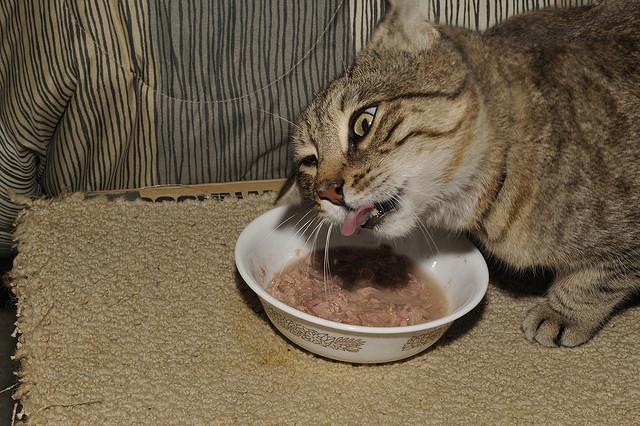What surface is the cat laying on?
Quick response, please. Rug. Do felines sleep?
Write a very short answer. Yes. What are the owners trying to do with the object under the cat?
Be succinct. Feed him. What color is the cat's collar?
Be succinct. Black. What is the bowl used for?
Answer briefly. Cat food. What color is the cup?
Concise answer only. White. Will the cat eat all of the food?
Concise answer only. Yes. How many cats are in the scene?
Write a very short answer. 1. Is the kitten adorable?
Keep it brief. Yes. What color is the bowl on the left?
Quick response, please. White. Is the cat sleeping?
Be succinct. No. Is this bowl too big for the kitten?
Concise answer only. No. Does the cat have on a collar?
Write a very short answer. No. What is the cat eating?
Answer briefly. Tuna. What color is the cat?
Keep it brief. Brown. Does this cat look content?
Concise answer only. Yes. Is this the cat's usual water dish?
Keep it brief. No. What is this cat doing?
Short answer required. Eating. What is the cat looking at?
Short answer required. Camera. What is the cat doing?
Give a very brief answer. Eating. What is inside of the bowl?
Concise answer only. Cat food. Is it sunny?
Write a very short answer. No. Does the bowl match the carpeting?
Quick response, please. No. What is the bowl on?
Be succinct. Carpet. How many of the cat's ears are visible?
Keep it brief. 1. What is the cat drinking?
Quick response, please. Soup. Is the cat eating?
Be succinct. Yes. What color is the cat's nose?
Concise answer only. Pink. What is the cat being fed?
Quick response, please. Tuna. What are the cats doing?
Write a very short answer. Eating. What color are the cats paws?
Concise answer only. Brown. 